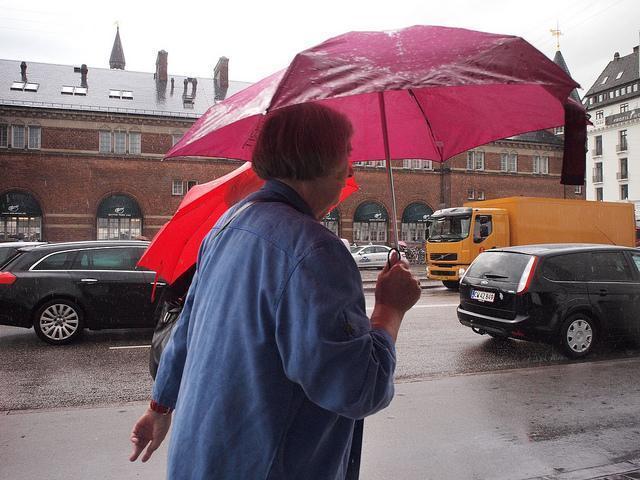How many umbrellas are in the photo?
Give a very brief answer. 2. How many umbrellas are in the picture?
Give a very brief answer. 2. How many cars can be seen?
Give a very brief answer. 2. 